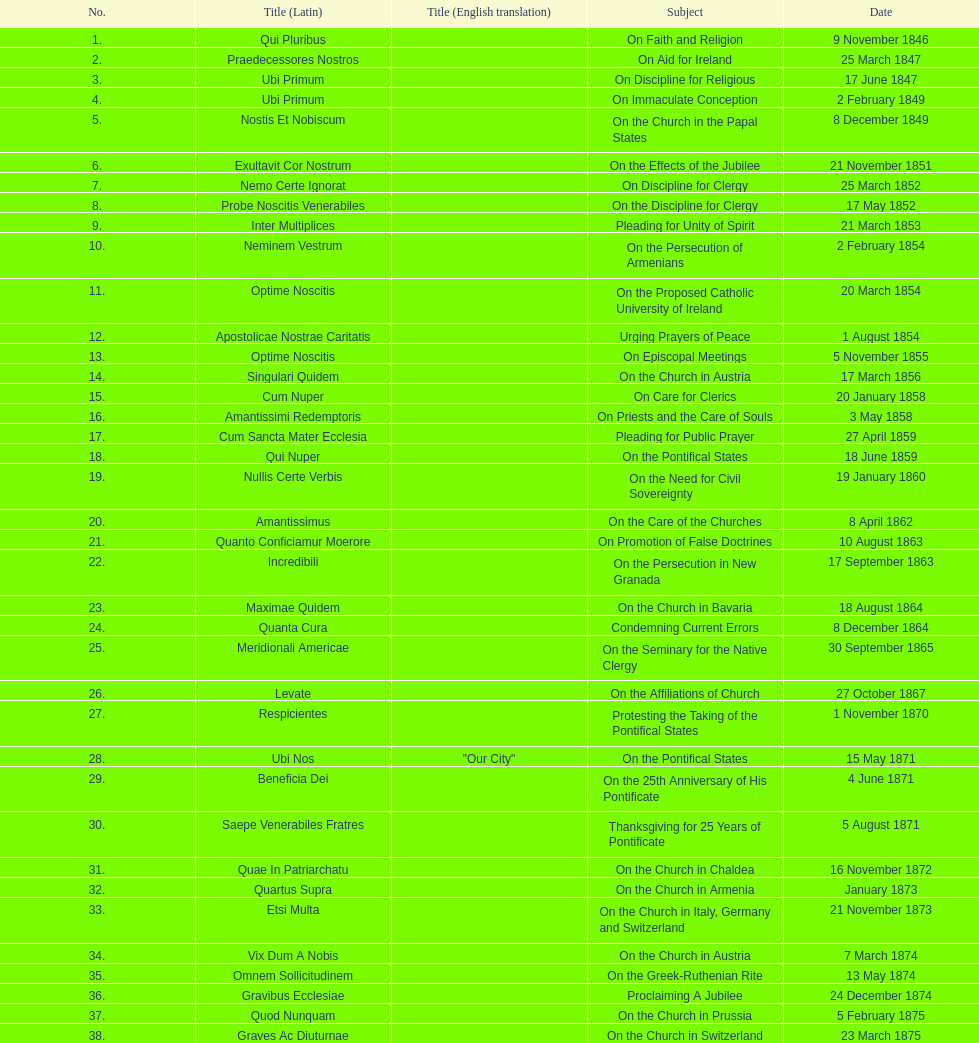When did the latest encyclical discussing a theme with the word "pontificate" occur? 5 August 1871. 